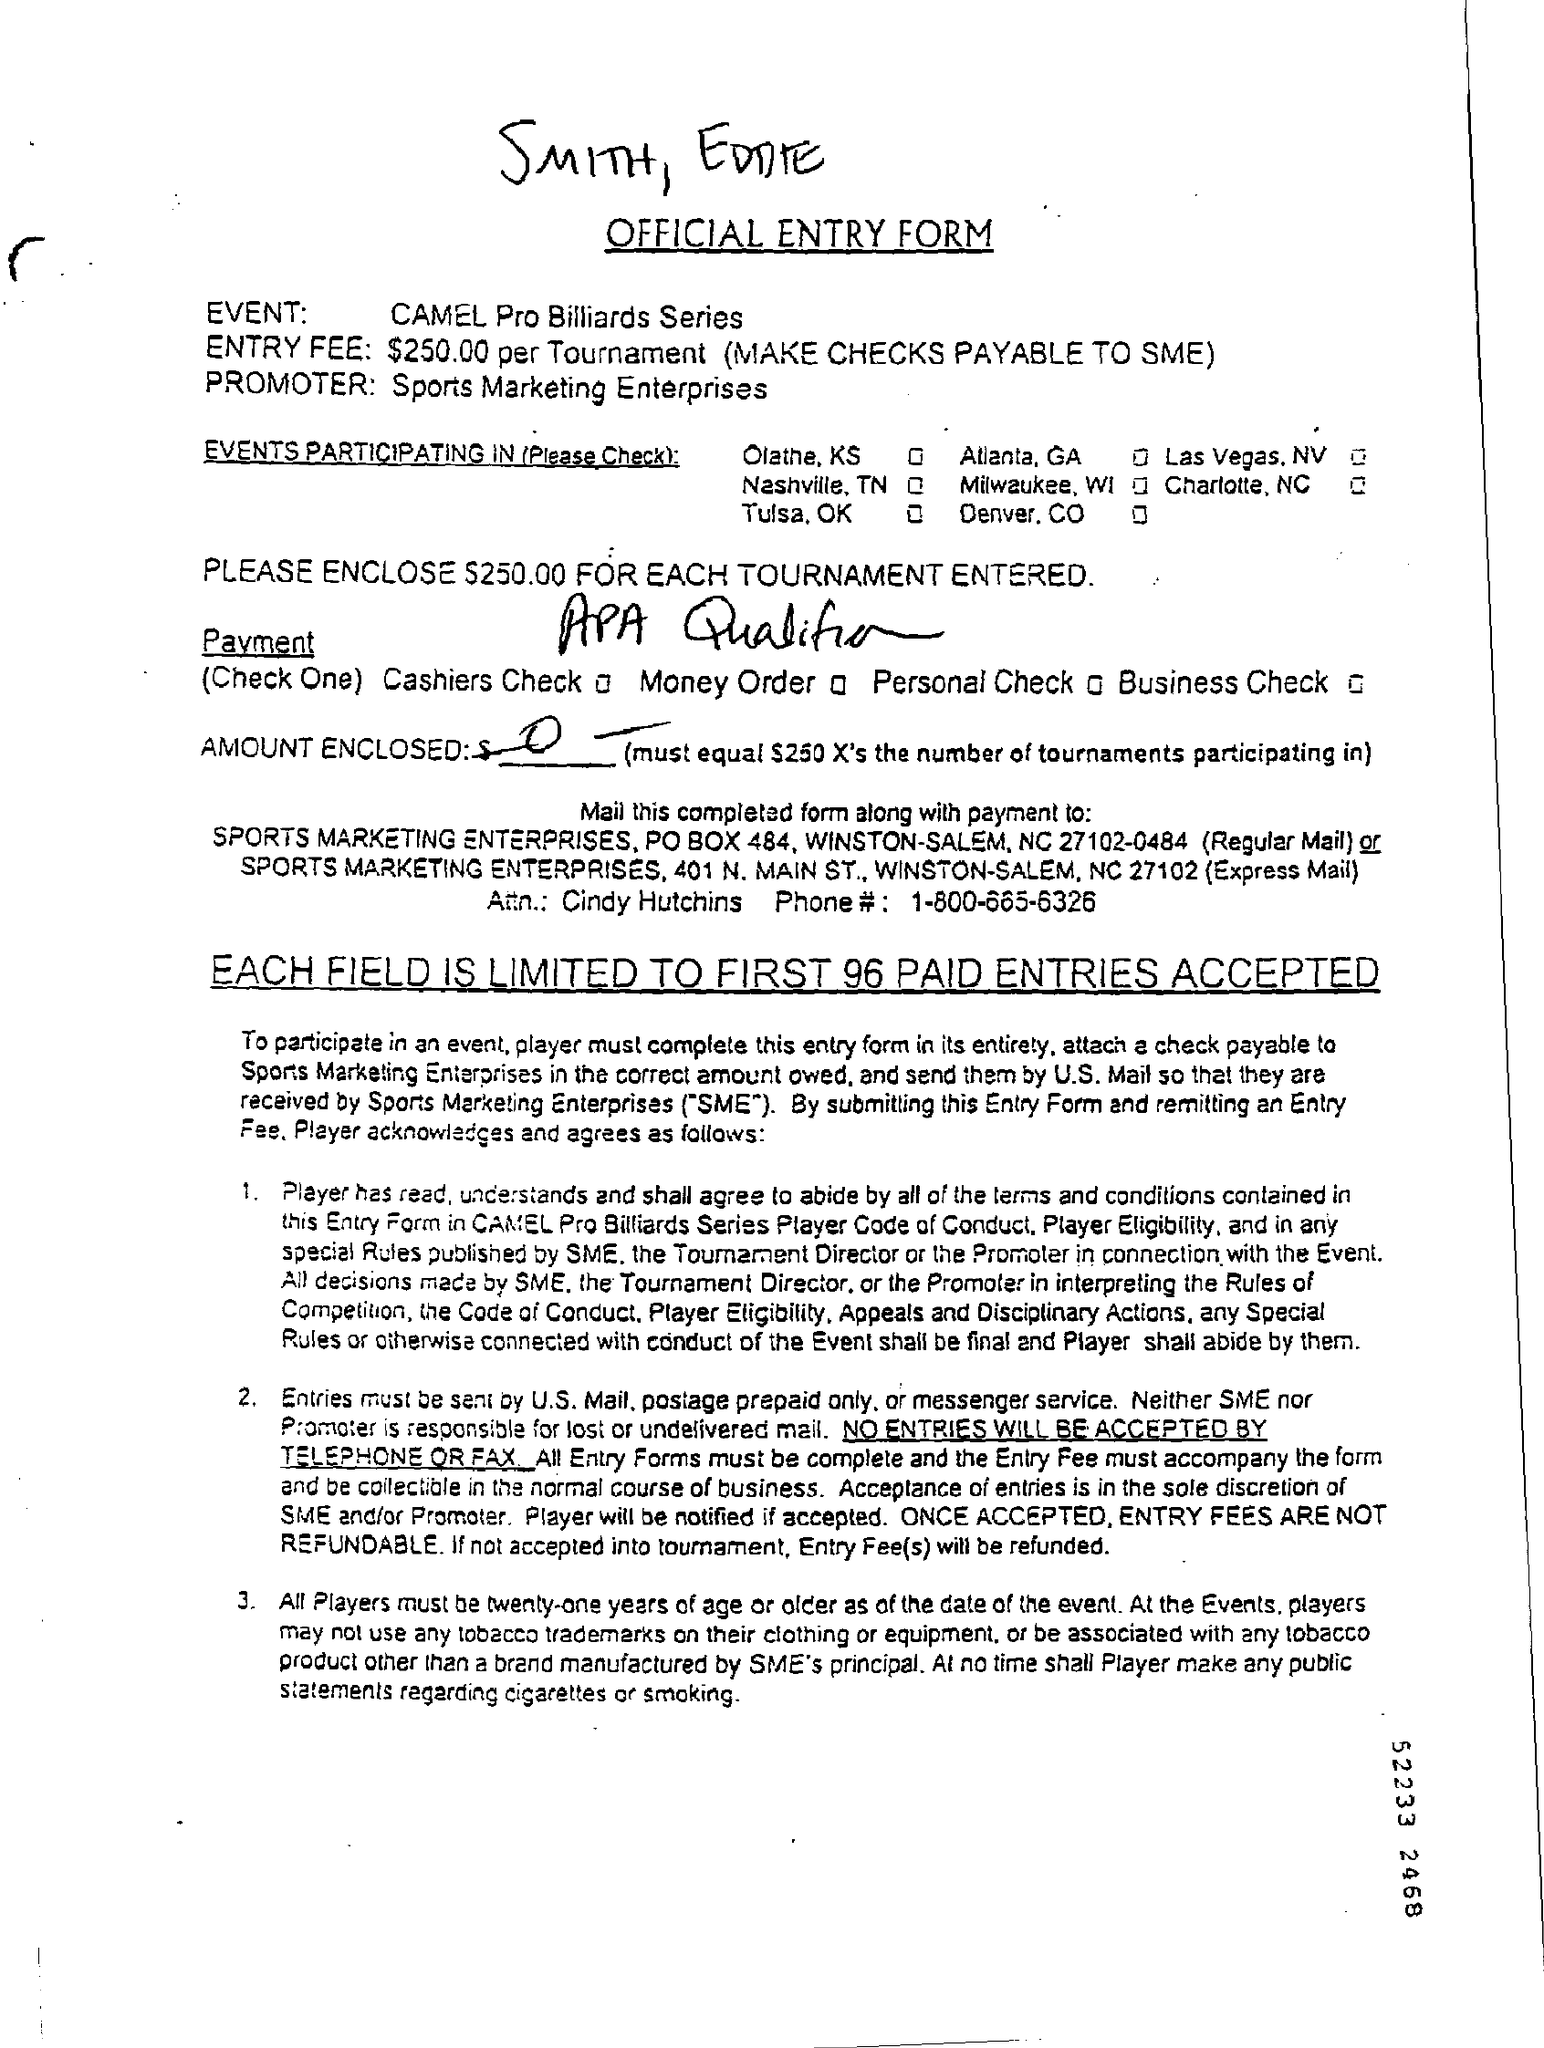Indicate a few pertinent items in this graphic. The promoter listed in the official entry form is Sports Marketing Enterprises. The event in question is the Camel Pro Billiards Series. Sports Marketing Enterprises (SME) is a full form of an organization that specializes in promoting and marketing sports-related activities and events. The entry fee for each tournament, as stated in the official entry form, is $250.00. The phone number mentioned in the form is 1-800-665-6326. 